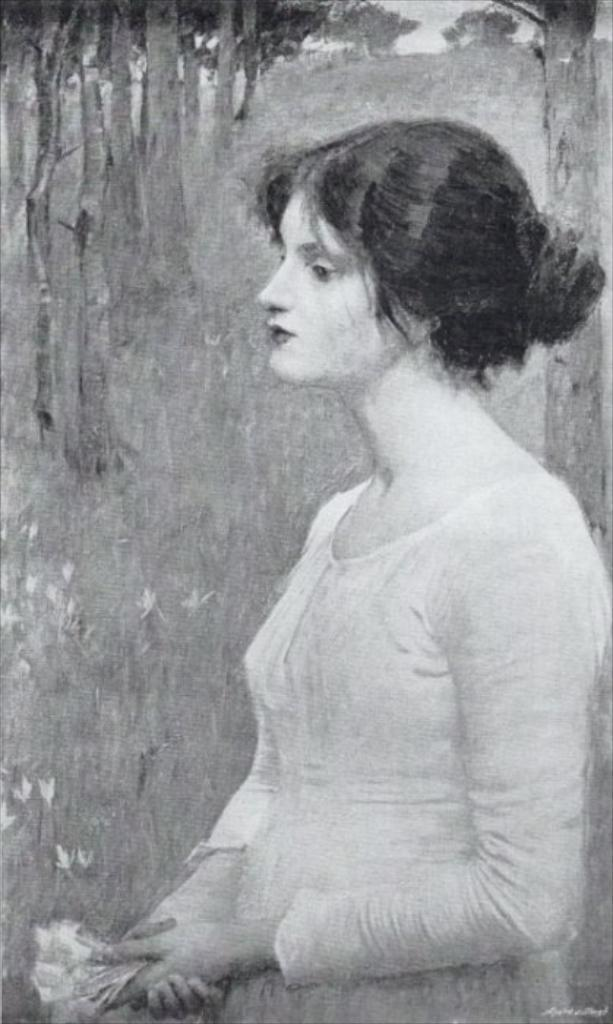What is the main subject of the painting in the image? The painting depicts a woman. What is the woman wearing in the painting? The woman is wearing a white dress in the painting. What is the woman holding in her hands in the painting? The woman is holding an object in her hands in the painting. What can be seen in the background of the painting? There are trees in the background of the painting. What type of nerve can be seen in the woman's hands in the painting? There is no nerve visible in the woman's hands in the painting; she is holding an object. Is there any soda visible in the painting? There is no soda present in the painting; it depicts a woman holding an object and trees in the background. 